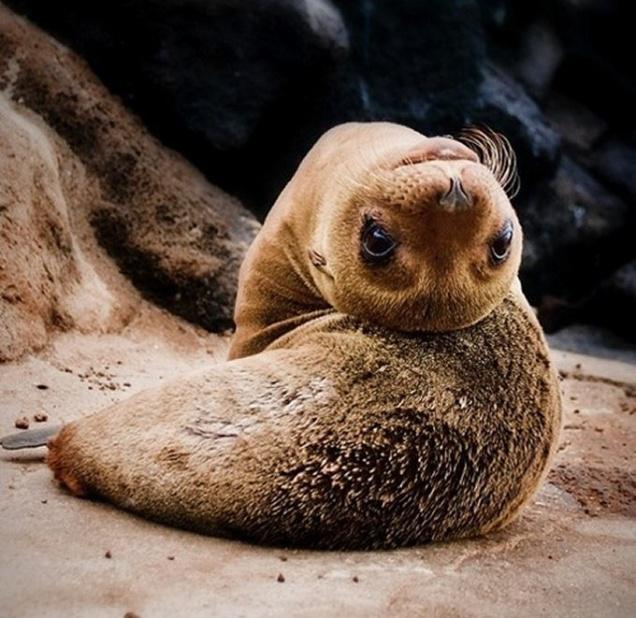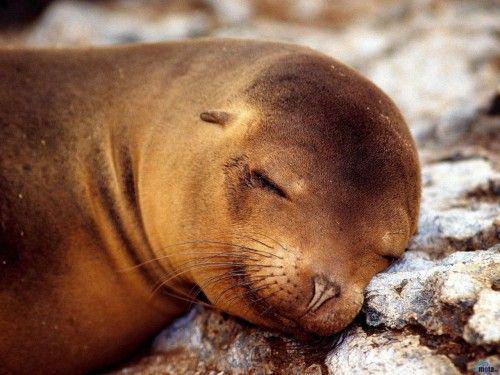The first image is the image on the left, the second image is the image on the right. Considering the images on both sides, is "There are less than two sea mammals sunning in each of the images." valid? Answer yes or no. Yes. The first image is the image on the left, the second image is the image on the right. Considering the images on both sides, is "An image shows three seals sleeping side-by-side." valid? Answer yes or no. No. 